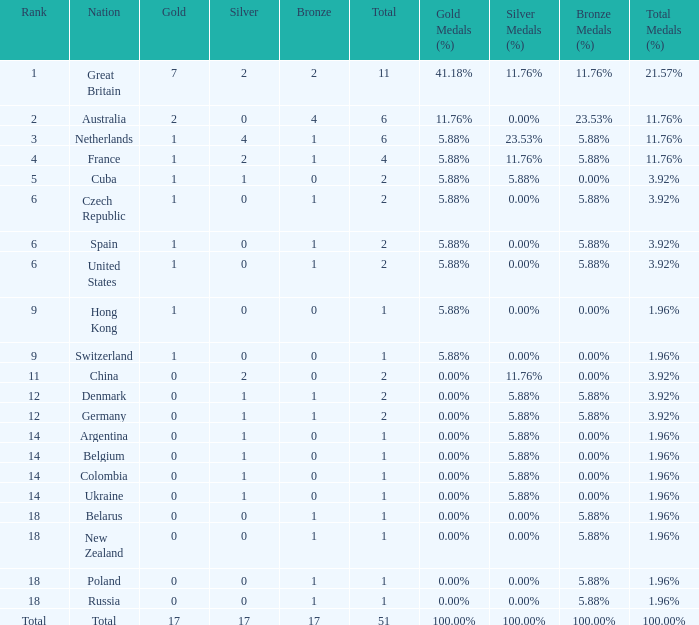Tell me the rank for bronze less than 17 and gold less than 1 11.0. 